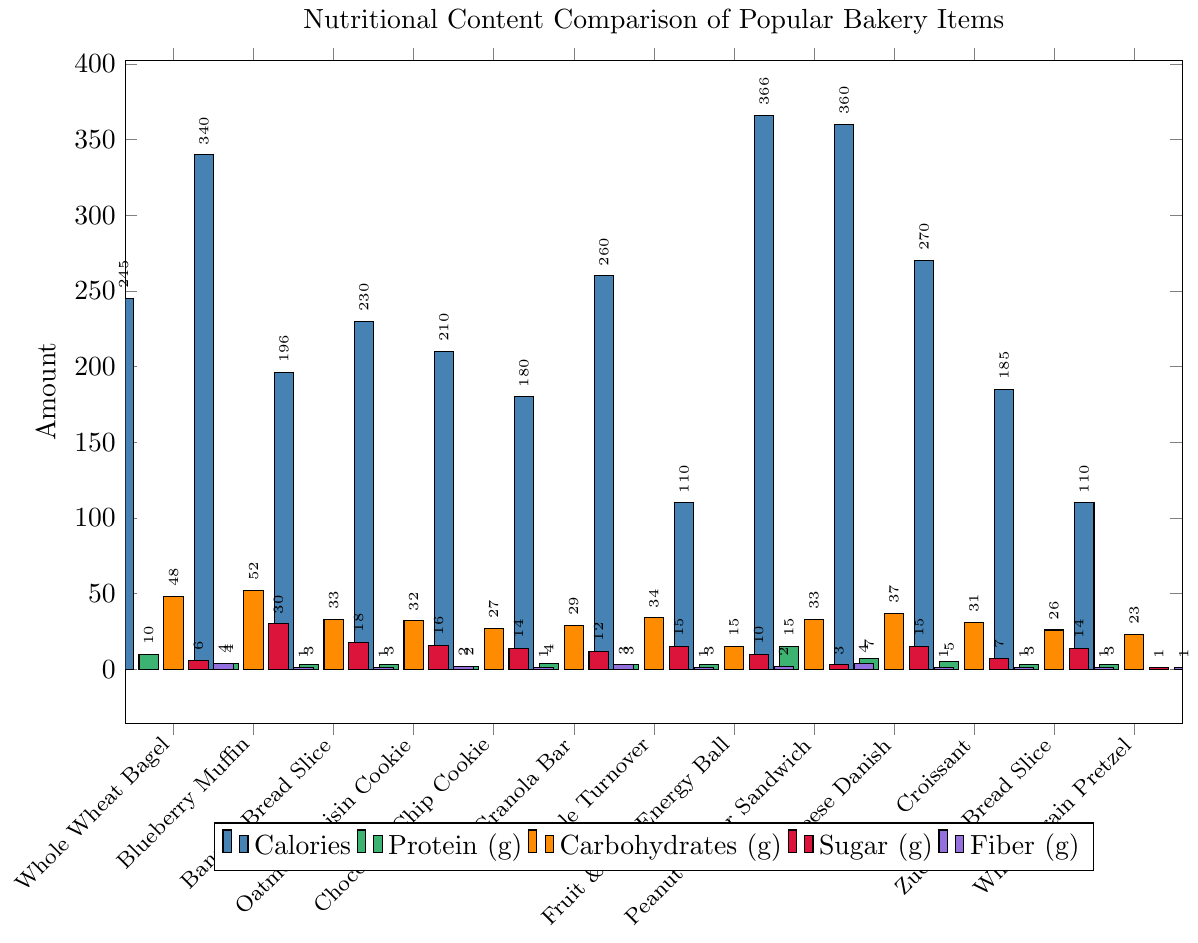What is the bakery item with the highest calories? To find the bakery item with the highest calories, look for the tallest bar in the blue color. The tallest blue bar corresponds to the Peanut Butter Sandwich, which has the highest calories.
Answer: Peanut Butter Sandwich Which two items have the same amount of fiber content? To identify items with the same amount of fiber content, look at the height of the purple bars. Both Whole Wheat Bagel and Peanut Butter Sandwich have the same height purple bars, indicating they both have 4 grams of fiber.
Answer: Whole Wheat Bagel and Peanut Butter Sandwich What is the difference in sugar content between the Blueberry Muffin and the Oatmeal Raisin Cookie? Identify the red bars corresponding to both items and note their heights. The Blueberry Muffin has a red bar of 30 grams and the Oatmeal Raisin Cookie has a red bar of 16 grams. The difference is 30 - 16 = 14 grams.
Answer: 14 grams Which item has the lowest carbohydrates content? Find the shortest bar in the orange color. The Fruit & Nut Energy Ball has the shortest orange bar, indicating it has the lowest carbohydrates content of 15 grams.
Answer: Fruit & Nut Energy Ball How does the protein content of the Cheese Danish compare to the Whole Wheat Bagel? Compare the green bars' heights for both items. The Cheese Danish has a green bar with 7 grams of protein, and the Whole Wheat Bagel has a green bar with 10 grams of protein. The Whole Wheat Bagel has more protein.
Answer: Whole Wheat Bagel has more protein What is the total carbohydrate content of the Apple Turnover and the Croissant combined? Add the values of the orange bars for both items. The carbohydrate content for Apple Turnover is 34 grams and for Croissant is 31 grams. The total is 34 + 31 = 65 grams.
Answer: 65 grams Which items have an equal amount of protein? Check for green bars of equal height. The Blueberry Muffin, Granola Bar, Apple Turnover, Fruit & Nut Energy Ball, Oatmeal Raisin Cookie, Banana Bread Slice, Zucchini Bread Slice, and Whole Grain Pretzel, all have a green bar of 3 grams of protein.
Answer: Banana Bread Slice, Oatmeal Raisin Cookie, Granola Bar, Apple Turnover, Fruit & Nut Energy Ball, Zucchini Bread Slice, Whole Grain Pretzel What is the average sugar content of the three items with the highest sugar? Identify the three tallest red bars. The Blueberry Muffin, Banana Bread Slice, and Oatmeal Raisin Cookie have the highest sugar contents of 30g, 18g, and 16g respectively. Calculate the average: (30 + 18 + 16) / 3 = 21.33 grams.
Answer: 21.33 grams 